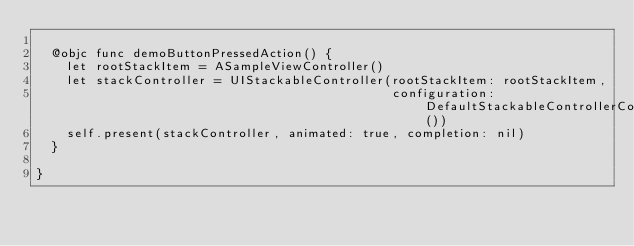Convert code to text. <code><loc_0><loc_0><loc_500><loc_500><_Swift_>
  @objc func demoButtonPressedAction() {
    let rootStackItem = ASampleViewController()
    let stackController = UIStackableController(rootStackItem: rootStackItem,
                                                configuration: DefaultStackableControllerConfiguration())
    self.present(stackController, animated: true, completion: nil)
  }

}
</code> 